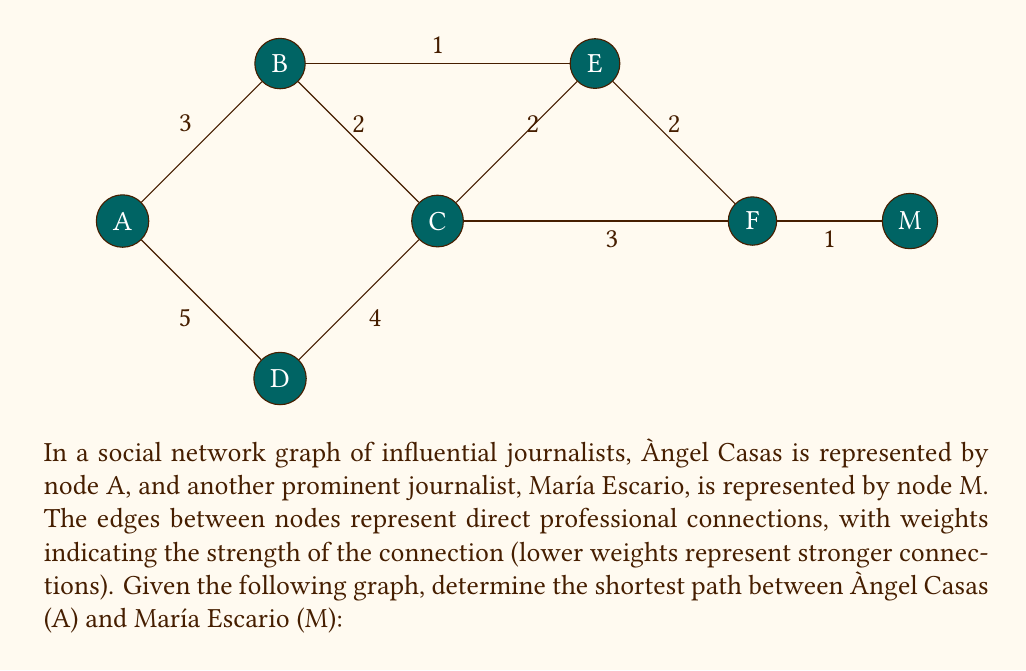Give your solution to this math problem. To solve this problem, we'll use Dijkstra's algorithm to find the shortest path between nodes A and M. 

1) Initialize:
   - Distance to A: 0
   - Distance to all other nodes: $\infty$
   - Set of unvisited nodes: {A, B, C, D, E, F, M}

2) From A:
   - Update distances: B(3), D(5)
   - Select B (shorter distance)

3) From B:
   - Update distances: C(5), E(4)
   - Select E (shortest unvisited)

4) From E:
   - Update distances: F(6)
   - Select C (shortest unvisited)

5) From C:
   - No updates (all connected nodes have shorter paths)
   - Select F (shortest unvisited)

6) From F:
   - Update distances: M(7)
   - Select M (only unvisited node left)

The shortest path is thus A -> B -> E -> F -> M, with a total distance of 7.

This path represents the most efficient way for information or influence to flow between Àngel Casas and María Escario in this professional network, considering the strength of connections between intermediary journalists.
Answer: The shortest path between Àngel Casas (A) and María Escario (M) is A -> B -> E -> F -> M, with a total distance of 7. 